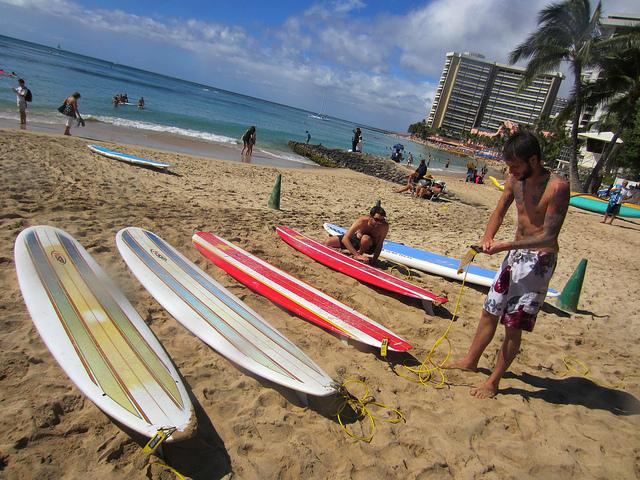What lessons are being taught?
Keep it brief. Surfing. Are there any dead leaves on the ground?
Quick response, please. No. Are these skateboards?
Give a very brief answer. No. Can you go swimming here?
Answer briefly. Yes. How many surfboards are shown?
Give a very brief answer. 6. 